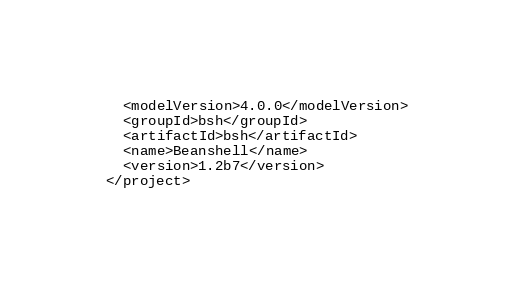<code> <loc_0><loc_0><loc_500><loc_500><_XML_>  <modelVersion>4.0.0</modelVersion>
  <groupId>bsh</groupId>
  <artifactId>bsh</artifactId>
  <name>Beanshell</name>
  <version>1.2b7</version>
</project>
</code> 